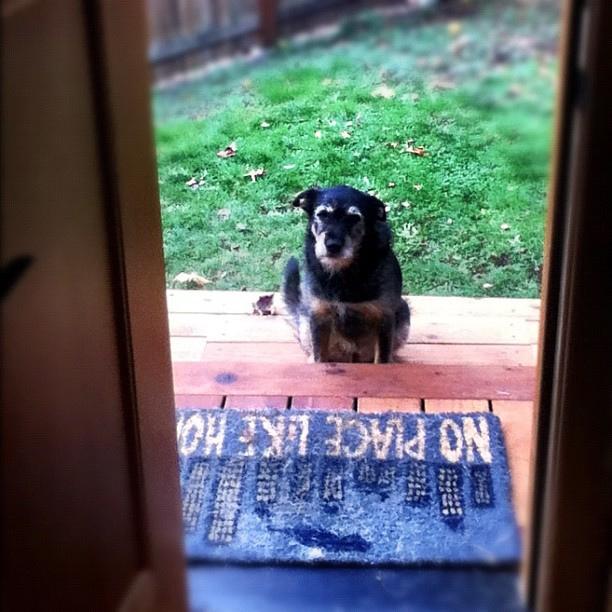Is there a dog waiting at the door?
Give a very brief answer. Yes. Where is the dog?
Give a very brief answer. Outside. What does the welcome mat say?
Concise answer only. No place like home. 